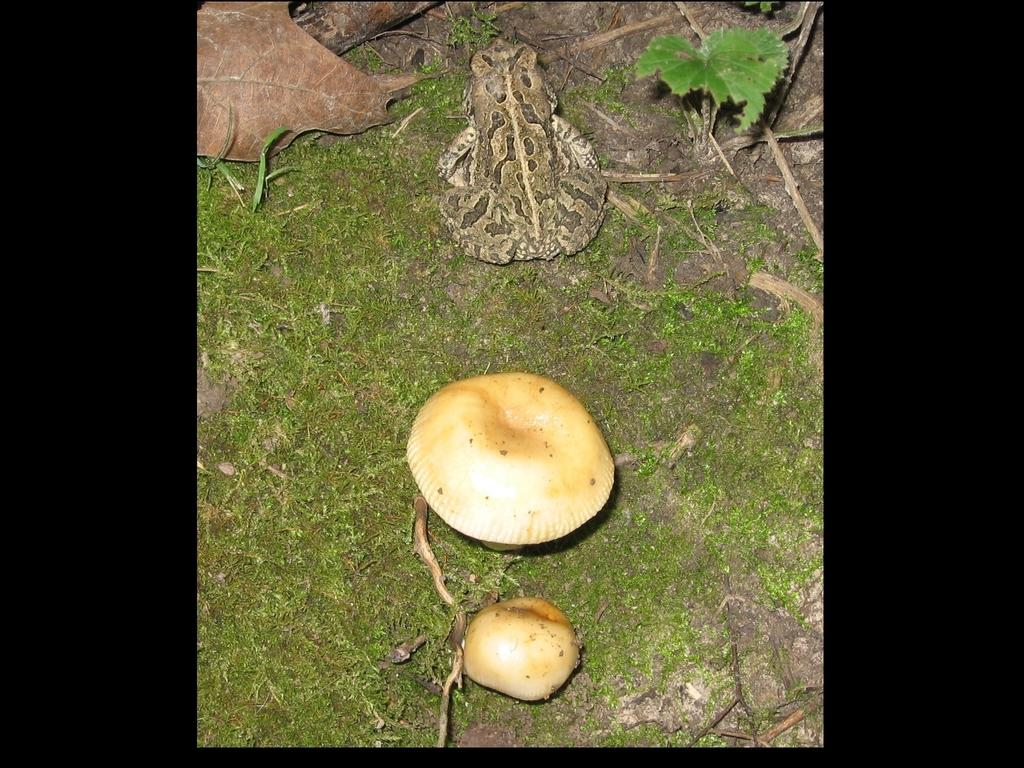What type of fungi can be seen in the image? There are mushrooms in the image. What is visible beneath the mushrooms in the image? The ground is visible in the image. What type of plant material is present in the image? There are leaves in the image. What is the object with a distinct pattern in the image? There is a flag in the image. How does the mushroom end its friendship with the leaf in the image? There is no indication of a friendship between the mushroom and the leaf in the image, nor is there any action taking place between them. 